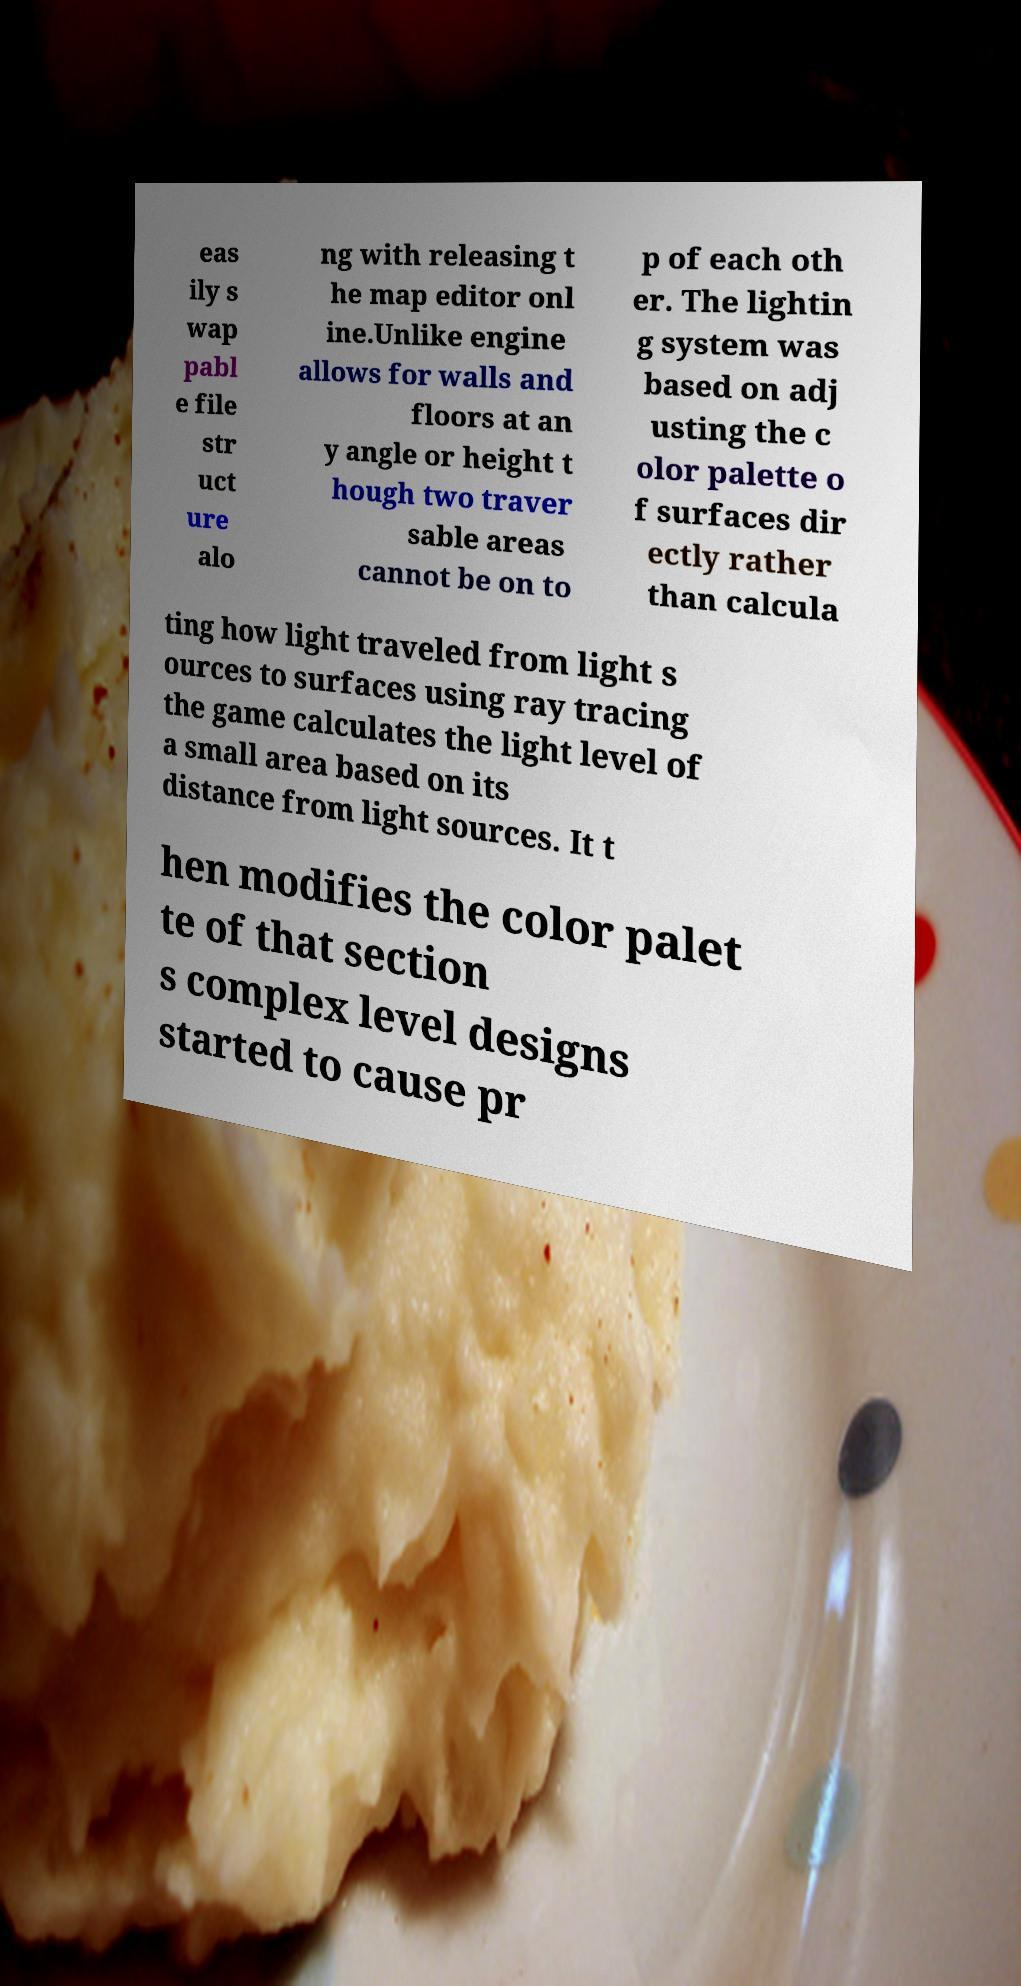Could you assist in decoding the text presented in this image and type it out clearly? eas ily s wap pabl e file str uct ure alo ng with releasing t he map editor onl ine.Unlike engine allows for walls and floors at an y angle or height t hough two traver sable areas cannot be on to p of each oth er. The lightin g system was based on adj usting the c olor palette o f surfaces dir ectly rather than calcula ting how light traveled from light s ources to surfaces using ray tracing the game calculates the light level of a small area based on its distance from light sources. It t hen modifies the color palet te of that section s complex level designs started to cause pr 